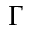Convert formula to latex. <formula><loc_0><loc_0><loc_500><loc_500>\Gamma</formula> 